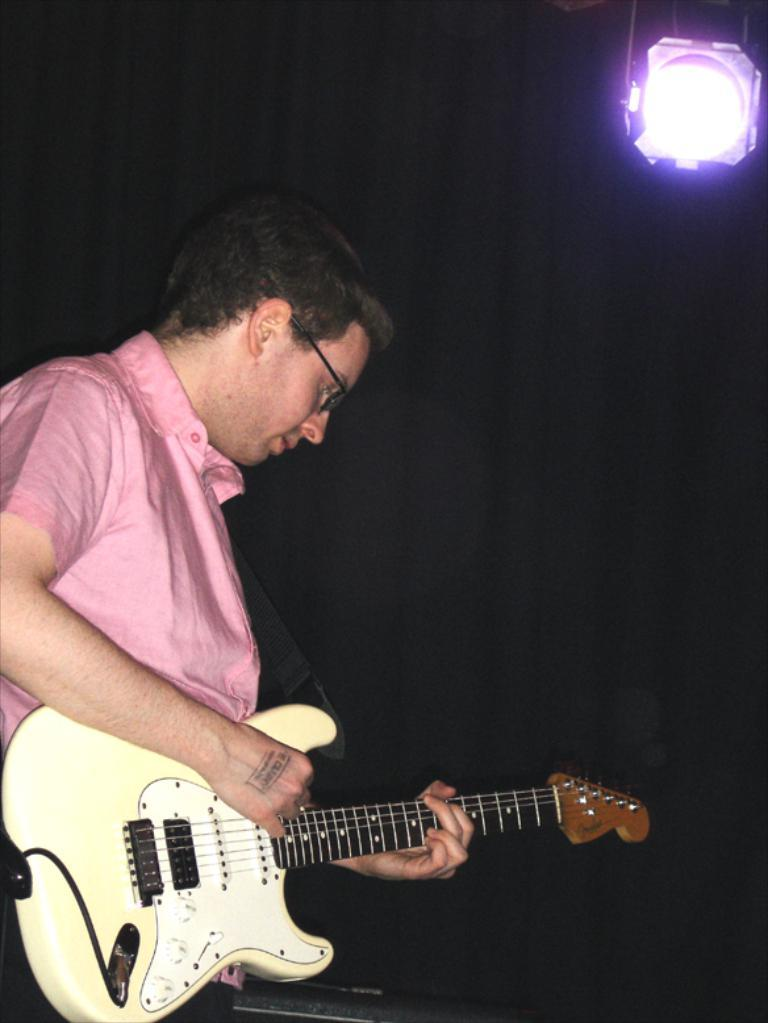Who is present in the image? There is a person in the image. What is the person wearing? The person is wearing a pink shirt. What is the person holding in the image? The person is holding a guitar. What can be seen in the background of the image? There is a light in the background of the image. What type of appliance is the person using to whistle in the image? There is no appliance or whistling present in the image; the person is holding a guitar. Can you see any teeth in the image? There is no indication of teeth in the image, as the person's mouth is not visible. 